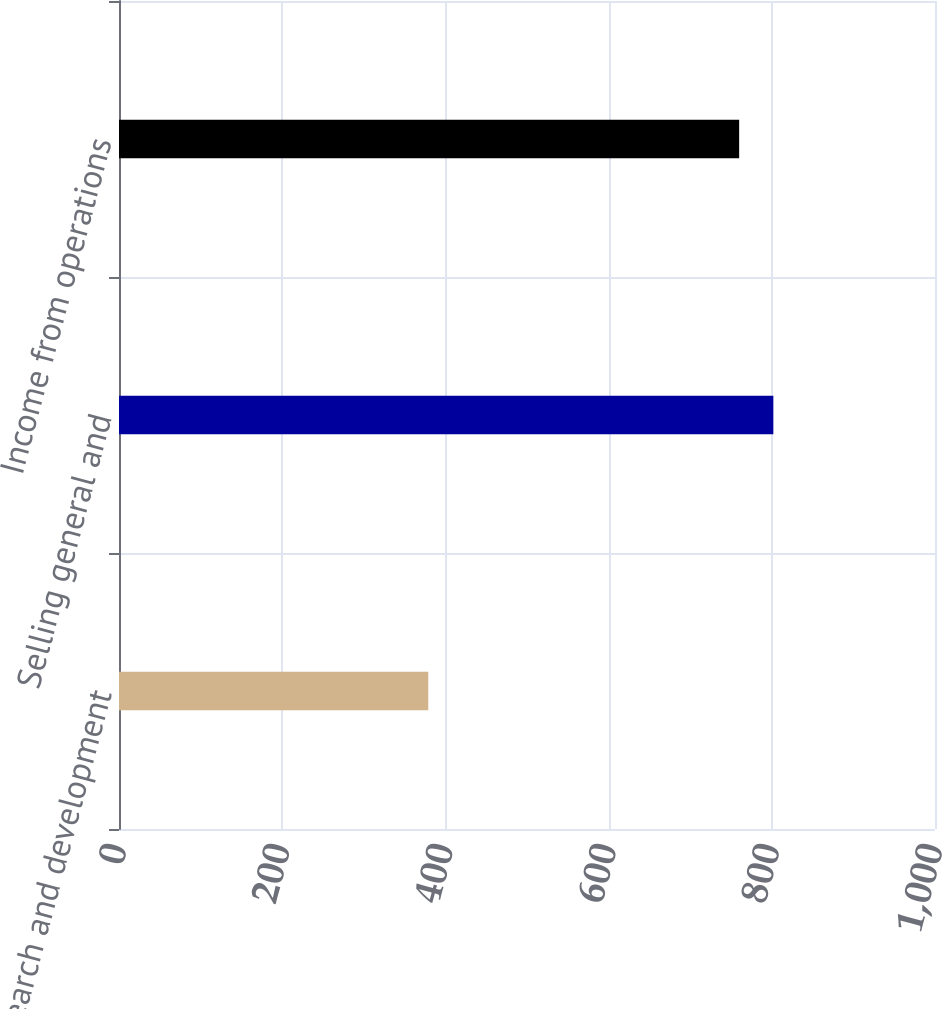Convert chart to OTSL. <chart><loc_0><loc_0><loc_500><loc_500><bar_chart><fcel>Research and development<fcel>Selling general and<fcel>Income from operations<nl><fcel>379<fcel>801.9<fcel>760<nl></chart> 